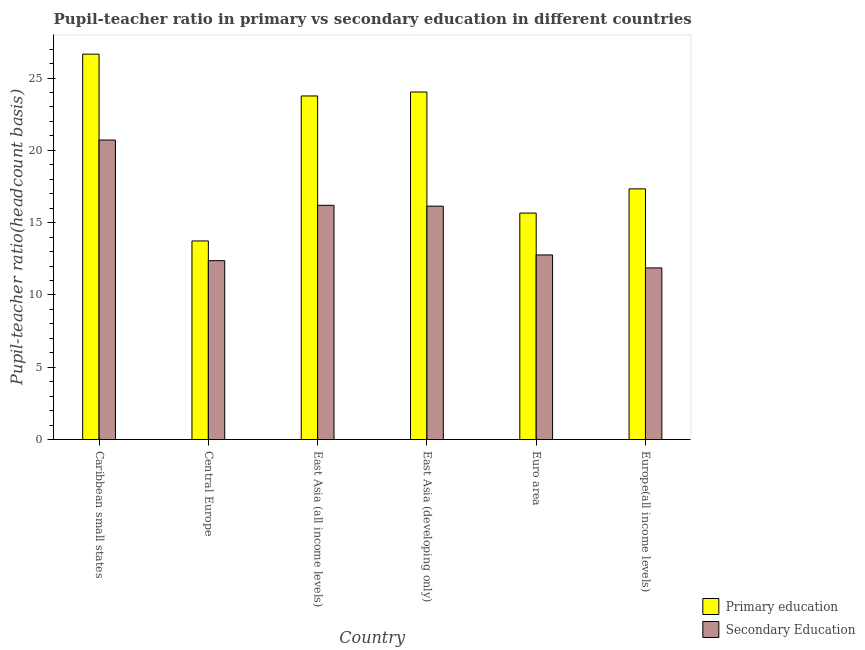How many different coloured bars are there?
Offer a terse response. 2. How many groups of bars are there?
Your answer should be very brief. 6. Are the number of bars per tick equal to the number of legend labels?
Your response must be concise. Yes. How many bars are there on the 6th tick from the left?
Your answer should be compact. 2. What is the label of the 4th group of bars from the left?
Your answer should be very brief. East Asia (developing only). What is the pupil teacher ratio on secondary education in Central Europe?
Your answer should be very brief. 12.37. Across all countries, what is the maximum pupil-teacher ratio in primary education?
Make the answer very short. 26.65. Across all countries, what is the minimum pupil teacher ratio on secondary education?
Offer a terse response. 11.87. In which country was the pupil teacher ratio on secondary education maximum?
Offer a very short reply. Caribbean small states. In which country was the pupil-teacher ratio in primary education minimum?
Make the answer very short. Central Europe. What is the total pupil teacher ratio on secondary education in the graph?
Your answer should be very brief. 90.05. What is the difference between the pupil teacher ratio on secondary education in Caribbean small states and that in Central Europe?
Your answer should be very brief. 8.34. What is the difference between the pupil teacher ratio on secondary education in Euro area and the pupil-teacher ratio in primary education in East Asia (all income levels)?
Offer a terse response. -11. What is the average pupil-teacher ratio in primary education per country?
Ensure brevity in your answer.  20.19. What is the difference between the pupil teacher ratio on secondary education and pupil-teacher ratio in primary education in Caribbean small states?
Make the answer very short. -5.94. In how many countries, is the pupil teacher ratio on secondary education greater than 25 ?
Offer a very short reply. 0. What is the ratio of the pupil teacher ratio on secondary education in Central Europe to that in Euro area?
Offer a terse response. 0.97. Is the pupil-teacher ratio in primary education in East Asia (developing only) less than that in Europe(all income levels)?
Ensure brevity in your answer.  No. What is the difference between the highest and the second highest pupil-teacher ratio in primary education?
Your answer should be compact. 2.62. What is the difference between the highest and the lowest pupil-teacher ratio in primary education?
Provide a succinct answer. 12.92. What does the 2nd bar from the left in East Asia (developing only) represents?
Make the answer very short. Secondary Education. Are all the bars in the graph horizontal?
Your answer should be compact. No. Does the graph contain any zero values?
Your answer should be compact. No. How many legend labels are there?
Your answer should be very brief. 2. What is the title of the graph?
Provide a short and direct response. Pupil-teacher ratio in primary vs secondary education in different countries. Does "Subsidies" appear as one of the legend labels in the graph?
Provide a succinct answer. No. What is the label or title of the X-axis?
Keep it short and to the point. Country. What is the label or title of the Y-axis?
Give a very brief answer. Pupil-teacher ratio(headcount basis). What is the Pupil-teacher ratio(headcount basis) of Primary education in Caribbean small states?
Offer a terse response. 26.65. What is the Pupil-teacher ratio(headcount basis) in Secondary Education in Caribbean small states?
Your response must be concise. 20.71. What is the Pupil-teacher ratio(headcount basis) of Primary education in Central Europe?
Your response must be concise. 13.73. What is the Pupil-teacher ratio(headcount basis) of Secondary Education in Central Europe?
Make the answer very short. 12.37. What is the Pupil-teacher ratio(headcount basis) in Primary education in East Asia (all income levels)?
Offer a terse response. 23.76. What is the Pupil-teacher ratio(headcount basis) of Secondary Education in East Asia (all income levels)?
Make the answer very short. 16.2. What is the Pupil-teacher ratio(headcount basis) in Primary education in East Asia (developing only)?
Offer a terse response. 24.03. What is the Pupil-teacher ratio(headcount basis) of Secondary Education in East Asia (developing only)?
Your answer should be compact. 16.14. What is the Pupil-teacher ratio(headcount basis) in Primary education in Euro area?
Offer a very short reply. 15.66. What is the Pupil-teacher ratio(headcount basis) in Secondary Education in Euro area?
Offer a terse response. 12.76. What is the Pupil-teacher ratio(headcount basis) in Primary education in Europe(all income levels)?
Ensure brevity in your answer.  17.33. What is the Pupil-teacher ratio(headcount basis) of Secondary Education in Europe(all income levels)?
Offer a very short reply. 11.87. Across all countries, what is the maximum Pupil-teacher ratio(headcount basis) of Primary education?
Make the answer very short. 26.65. Across all countries, what is the maximum Pupil-teacher ratio(headcount basis) in Secondary Education?
Provide a succinct answer. 20.71. Across all countries, what is the minimum Pupil-teacher ratio(headcount basis) in Primary education?
Your answer should be very brief. 13.73. Across all countries, what is the minimum Pupil-teacher ratio(headcount basis) in Secondary Education?
Offer a terse response. 11.87. What is the total Pupil-teacher ratio(headcount basis) of Primary education in the graph?
Your response must be concise. 121.17. What is the total Pupil-teacher ratio(headcount basis) of Secondary Education in the graph?
Your answer should be compact. 90.05. What is the difference between the Pupil-teacher ratio(headcount basis) of Primary education in Caribbean small states and that in Central Europe?
Ensure brevity in your answer.  12.92. What is the difference between the Pupil-teacher ratio(headcount basis) in Secondary Education in Caribbean small states and that in Central Europe?
Offer a very short reply. 8.34. What is the difference between the Pupil-teacher ratio(headcount basis) in Primary education in Caribbean small states and that in East Asia (all income levels)?
Provide a short and direct response. 2.89. What is the difference between the Pupil-teacher ratio(headcount basis) of Secondary Education in Caribbean small states and that in East Asia (all income levels)?
Ensure brevity in your answer.  4.51. What is the difference between the Pupil-teacher ratio(headcount basis) of Primary education in Caribbean small states and that in East Asia (developing only)?
Your response must be concise. 2.62. What is the difference between the Pupil-teacher ratio(headcount basis) in Secondary Education in Caribbean small states and that in East Asia (developing only)?
Your response must be concise. 4.57. What is the difference between the Pupil-teacher ratio(headcount basis) of Primary education in Caribbean small states and that in Euro area?
Give a very brief answer. 10.99. What is the difference between the Pupil-teacher ratio(headcount basis) in Secondary Education in Caribbean small states and that in Euro area?
Your response must be concise. 7.95. What is the difference between the Pupil-teacher ratio(headcount basis) in Primary education in Caribbean small states and that in Europe(all income levels)?
Provide a short and direct response. 9.32. What is the difference between the Pupil-teacher ratio(headcount basis) in Secondary Education in Caribbean small states and that in Europe(all income levels)?
Ensure brevity in your answer.  8.84. What is the difference between the Pupil-teacher ratio(headcount basis) in Primary education in Central Europe and that in East Asia (all income levels)?
Give a very brief answer. -10.03. What is the difference between the Pupil-teacher ratio(headcount basis) in Secondary Education in Central Europe and that in East Asia (all income levels)?
Your response must be concise. -3.83. What is the difference between the Pupil-teacher ratio(headcount basis) of Primary education in Central Europe and that in East Asia (developing only)?
Make the answer very short. -10.3. What is the difference between the Pupil-teacher ratio(headcount basis) of Secondary Education in Central Europe and that in East Asia (developing only)?
Your response must be concise. -3.77. What is the difference between the Pupil-teacher ratio(headcount basis) of Primary education in Central Europe and that in Euro area?
Your answer should be very brief. -1.93. What is the difference between the Pupil-teacher ratio(headcount basis) in Secondary Education in Central Europe and that in Euro area?
Keep it short and to the point. -0.4. What is the difference between the Pupil-teacher ratio(headcount basis) of Primary education in Central Europe and that in Europe(all income levels)?
Keep it short and to the point. -3.6. What is the difference between the Pupil-teacher ratio(headcount basis) of Secondary Education in Central Europe and that in Europe(all income levels)?
Your answer should be compact. 0.5. What is the difference between the Pupil-teacher ratio(headcount basis) in Primary education in East Asia (all income levels) and that in East Asia (developing only)?
Make the answer very short. -0.27. What is the difference between the Pupil-teacher ratio(headcount basis) of Secondary Education in East Asia (all income levels) and that in East Asia (developing only)?
Provide a short and direct response. 0.06. What is the difference between the Pupil-teacher ratio(headcount basis) of Primary education in East Asia (all income levels) and that in Euro area?
Provide a short and direct response. 8.1. What is the difference between the Pupil-teacher ratio(headcount basis) of Secondary Education in East Asia (all income levels) and that in Euro area?
Make the answer very short. 3.43. What is the difference between the Pupil-teacher ratio(headcount basis) in Primary education in East Asia (all income levels) and that in Europe(all income levels)?
Your answer should be very brief. 6.43. What is the difference between the Pupil-teacher ratio(headcount basis) of Secondary Education in East Asia (all income levels) and that in Europe(all income levels)?
Provide a short and direct response. 4.33. What is the difference between the Pupil-teacher ratio(headcount basis) in Primary education in East Asia (developing only) and that in Euro area?
Your response must be concise. 8.37. What is the difference between the Pupil-teacher ratio(headcount basis) of Secondary Education in East Asia (developing only) and that in Euro area?
Your answer should be compact. 3.38. What is the difference between the Pupil-teacher ratio(headcount basis) in Primary education in East Asia (developing only) and that in Europe(all income levels)?
Your answer should be compact. 6.7. What is the difference between the Pupil-teacher ratio(headcount basis) in Secondary Education in East Asia (developing only) and that in Europe(all income levels)?
Make the answer very short. 4.27. What is the difference between the Pupil-teacher ratio(headcount basis) in Primary education in Euro area and that in Europe(all income levels)?
Offer a very short reply. -1.68. What is the difference between the Pupil-teacher ratio(headcount basis) in Secondary Education in Euro area and that in Europe(all income levels)?
Give a very brief answer. 0.9. What is the difference between the Pupil-teacher ratio(headcount basis) of Primary education in Caribbean small states and the Pupil-teacher ratio(headcount basis) of Secondary Education in Central Europe?
Your answer should be very brief. 14.28. What is the difference between the Pupil-teacher ratio(headcount basis) of Primary education in Caribbean small states and the Pupil-teacher ratio(headcount basis) of Secondary Education in East Asia (all income levels)?
Give a very brief answer. 10.45. What is the difference between the Pupil-teacher ratio(headcount basis) in Primary education in Caribbean small states and the Pupil-teacher ratio(headcount basis) in Secondary Education in East Asia (developing only)?
Make the answer very short. 10.51. What is the difference between the Pupil-teacher ratio(headcount basis) in Primary education in Caribbean small states and the Pupil-teacher ratio(headcount basis) in Secondary Education in Euro area?
Ensure brevity in your answer.  13.89. What is the difference between the Pupil-teacher ratio(headcount basis) in Primary education in Caribbean small states and the Pupil-teacher ratio(headcount basis) in Secondary Education in Europe(all income levels)?
Your response must be concise. 14.78. What is the difference between the Pupil-teacher ratio(headcount basis) in Primary education in Central Europe and the Pupil-teacher ratio(headcount basis) in Secondary Education in East Asia (all income levels)?
Ensure brevity in your answer.  -2.47. What is the difference between the Pupil-teacher ratio(headcount basis) of Primary education in Central Europe and the Pupil-teacher ratio(headcount basis) of Secondary Education in East Asia (developing only)?
Offer a very short reply. -2.41. What is the difference between the Pupil-teacher ratio(headcount basis) of Primary education in Central Europe and the Pupil-teacher ratio(headcount basis) of Secondary Education in Euro area?
Give a very brief answer. 0.97. What is the difference between the Pupil-teacher ratio(headcount basis) of Primary education in Central Europe and the Pupil-teacher ratio(headcount basis) of Secondary Education in Europe(all income levels)?
Your answer should be compact. 1.86. What is the difference between the Pupil-teacher ratio(headcount basis) in Primary education in East Asia (all income levels) and the Pupil-teacher ratio(headcount basis) in Secondary Education in East Asia (developing only)?
Provide a short and direct response. 7.62. What is the difference between the Pupil-teacher ratio(headcount basis) of Primary education in East Asia (all income levels) and the Pupil-teacher ratio(headcount basis) of Secondary Education in Euro area?
Your answer should be compact. 11. What is the difference between the Pupil-teacher ratio(headcount basis) in Primary education in East Asia (all income levels) and the Pupil-teacher ratio(headcount basis) in Secondary Education in Europe(all income levels)?
Ensure brevity in your answer.  11.89. What is the difference between the Pupil-teacher ratio(headcount basis) of Primary education in East Asia (developing only) and the Pupil-teacher ratio(headcount basis) of Secondary Education in Euro area?
Keep it short and to the point. 11.27. What is the difference between the Pupil-teacher ratio(headcount basis) in Primary education in East Asia (developing only) and the Pupil-teacher ratio(headcount basis) in Secondary Education in Europe(all income levels)?
Ensure brevity in your answer.  12.16. What is the difference between the Pupil-teacher ratio(headcount basis) in Primary education in Euro area and the Pupil-teacher ratio(headcount basis) in Secondary Education in Europe(all income levels)?
Offer a very short reply. 3.79. What is the average Pupil-teacher ratio(headcount basis) in Primary education per country?
Make the answer very short. 20.2. What is the average Pupil-teacher ratio(headcount basis) of Secondary Education per country?
Your answer should be compact. 15.01. What is the difference between the Pupil-teacher ratio(headcount basis) of Primary education and Pupil-teacher ratio(headcount basis) of Secondary Education in Caribbean small states?
Offer a very short reply. 5.94. What is the difference between the Pupil-teacher ratio(headcount basis) in Primary education and Pupil-teacher ratio(headcount basis) in Secondary Education in Central Europe?
Your response must be concise. 1.36. What is the difference between the Pupil-teacher ratio(headcount basis) of Primary education and Pupil-teacher ratio(headcount basis) of Secondary Education in East Asia (all income levels)?
Offer a terse response. 7.56. What is the difference between the Pupil-teacher ratio(headcount basis) in Primary education and Pupil-teacher ratio(headcount basis) in Secondary Education in East Asia (developing only)?
Keep it short and to the point. 7.89. What is the difference between the Pupil-teacher ratio(headcount basis) of Primary education and Pupil-teacher ratio(headcount basis) of Secondary Education in Euro area?
Provide a short and direct response. 2.89. What is the difference between the Pupil-teacher ratio(headcount basis) of Primary education and Pupil-teacher ratio(headcount basis) of Secondary Education in Europe(all income levels)?
Provide a short and direct response. 5.47. What is the ratio of the Pupil-teacher ratio(headcount basis) in Primary education in Caribbean small states to that in Central Europe?
Your answer should be compact. 1.94. What is the ratio of the Pupil-teacher ratio(headcount basis) in Secondary Education in Caribbean small states to that in Central Europe?
Ensure brevity in your answer.  1.67. What is the ratio of the Pupil-teacher ratio(headcount basis) in Primary education in Caribbean small states to that in East Asia (all income levels)?
Your response must be concise. 1.12. What is the ratio of the Pupil-teacher ratio(headcount basis) of Secondary Education in Caribbean small states to that in East Asia (all income levels)?
Make the answer very short. 1.28. What is the ratio of the Pupil-teacher ratio(headcount basis) of Primary education in Caribbean small states to that in East Asia (developing only)?
Your response must be concise. 1.11. What is the ratio of the Pupil-teacher ratio(headcount basis) in Secondary Education in Caribbean small states to that in East Asia (developing only)?
Offer a very short reply. 1.28. What is the ratio of the Pupil-teacher ratio(headcount basis) of Primary education in Caribbean small states to that in Euro area?
Offer a terse response. 1.7. What is the ratio of the Pupil-teacher ratio(headcount basis) in Secondary Education in Caribbean small states to that in Euro area?
Offer a terse response. 1.62. What is the ratio of the Pupil-teacher ratio(headcount basis) in Primary education in Caribbean small states to that in Europe(all income levels)?
Your answer should be compact. 1.54. What is the ratio of the Pupil-teacher ratio(headcount basis) in Secondary Education in Caribbean small states to that in Europe(all income levels)?
Give a very brief answer. 1.75. What is the ratio of the Pupil-teacher ratio(headcount basis) of Primary education in Central Europe to that in East Asia (all income levels)?
Give a very brief answer. 0.58. What is the ratio of the Pupil-teacher ratio(headcount basis) of Secondary Education in Central Europe to that in East Asia (all income levels)?
Your response must be concise. 0.76. What is the ratio of the Pupil-teacher ratio(headcount basis) in Secondary Education in Central Europe to that in East Asia (developing only)?
Offer a terse response. 0.77. What is the ratio of the Pupil-teacher ratio(headcount basis) in Primary education in Central Europe to that in Euro area?
Give a very brief answer. 0.88. What is the ratio of the Pupil-teacher ratio(headcount basis) in Secondary Education in Central Europe to that in Euro area?
Give a very brief answer. 0.97. What is the ratio of the Pupil-teacher ratio(headcount basis) in Primary education in Central Europe to that in Europe(all income levels)?
Provide a succinct answer. 0.79. What is the ratio of the Pupil-teacher ratio(headcount basis) of Secondary Education in Central Europe to that in Europe(all income levels)?
Provide a short and direct response. 1.04. What is the ratio of the Pupil-teacher ratio(headcount basis) in Secondary Education in East Asia (all income levels) to that in East Asia (developing only)?
Your response must be concise. 1. What is the ratio of the Pupil-teacher ratio(headcount basis) in Primary education in East Asia (all income levels) to that in Euro area?
Keep it short and to the point. 1.52. What is the ratio of the Pupil-teacher ratio(headcount basis) of Secondary Education in East Asia (all income levels) to that in Euro area?
Provide a succinct answer. 1.27. What is the ratio of the Pupil-teacher ratio(headcount basis) of Primary education in East Asia (all income levels) to that in Europe(all income levels)?
Your answer should be compact. 1.37. What is the ratio of the Pupil-teacher ratio(headcount basis) of Secondary Education in East Asia (all income levels) to that in Europe(all income levels)?
Offer a very short reply. 1.36. What is the ratio of the Pupil-teacher ratio(headcount basis) in Primary education in East Asia (developing only) to that in Euro area?
Offer a very short reply. 1.53. What is the ratio of the Pupil-teacher ratio(headcount basis) of Secondary Education in East Asia (developing only) to that in Euro area?
Offer a very short reply. 1.26. What is the ratio of the Pupil-teacher ratio(headcount basis) of Primary education in East Asia (developing only) to that in Europe(all income levels)?
Provide a succinct answer. 1.39. What is the ratio of the Pupil-teacher ratio(headcount basis) of Secondary Education in East Asia (developing only) to that in Europe(all income levels)?
Offer a very short reply. 1.36. What is the ratio of the Pupil-teacher ratio(headcount basis) of Primary education in Euro area to that in Europe(all income levels)?
Your answer should be very brief. 0.9. What is the ratio of the Pupil-teacher ratio(headcount basis) of Secondary Education in Euro area to that in Europe(all income levels)?
Offer a very short reply. 1.08. What is the difference between the highest and the second highest Pupil-teacher ratio(headcount basis) of Primary education?
Make the answer very short. 2.62. What is the difference between the highest and the second highest Pupil-teacher ratio(headcount basis) of Secondary Education?
Your answer should be very brief. 4.51. What is the difference between the highest and the lowest Pupil-teacher ratio(headcount basis) in Primary education?
Keep it short and to the point. 12.92. What is the difference between the highest and the lowest Pupil-teacher ratio(headcount basis) of Secondary Education?
Provide a succinct answer. 8.84. 